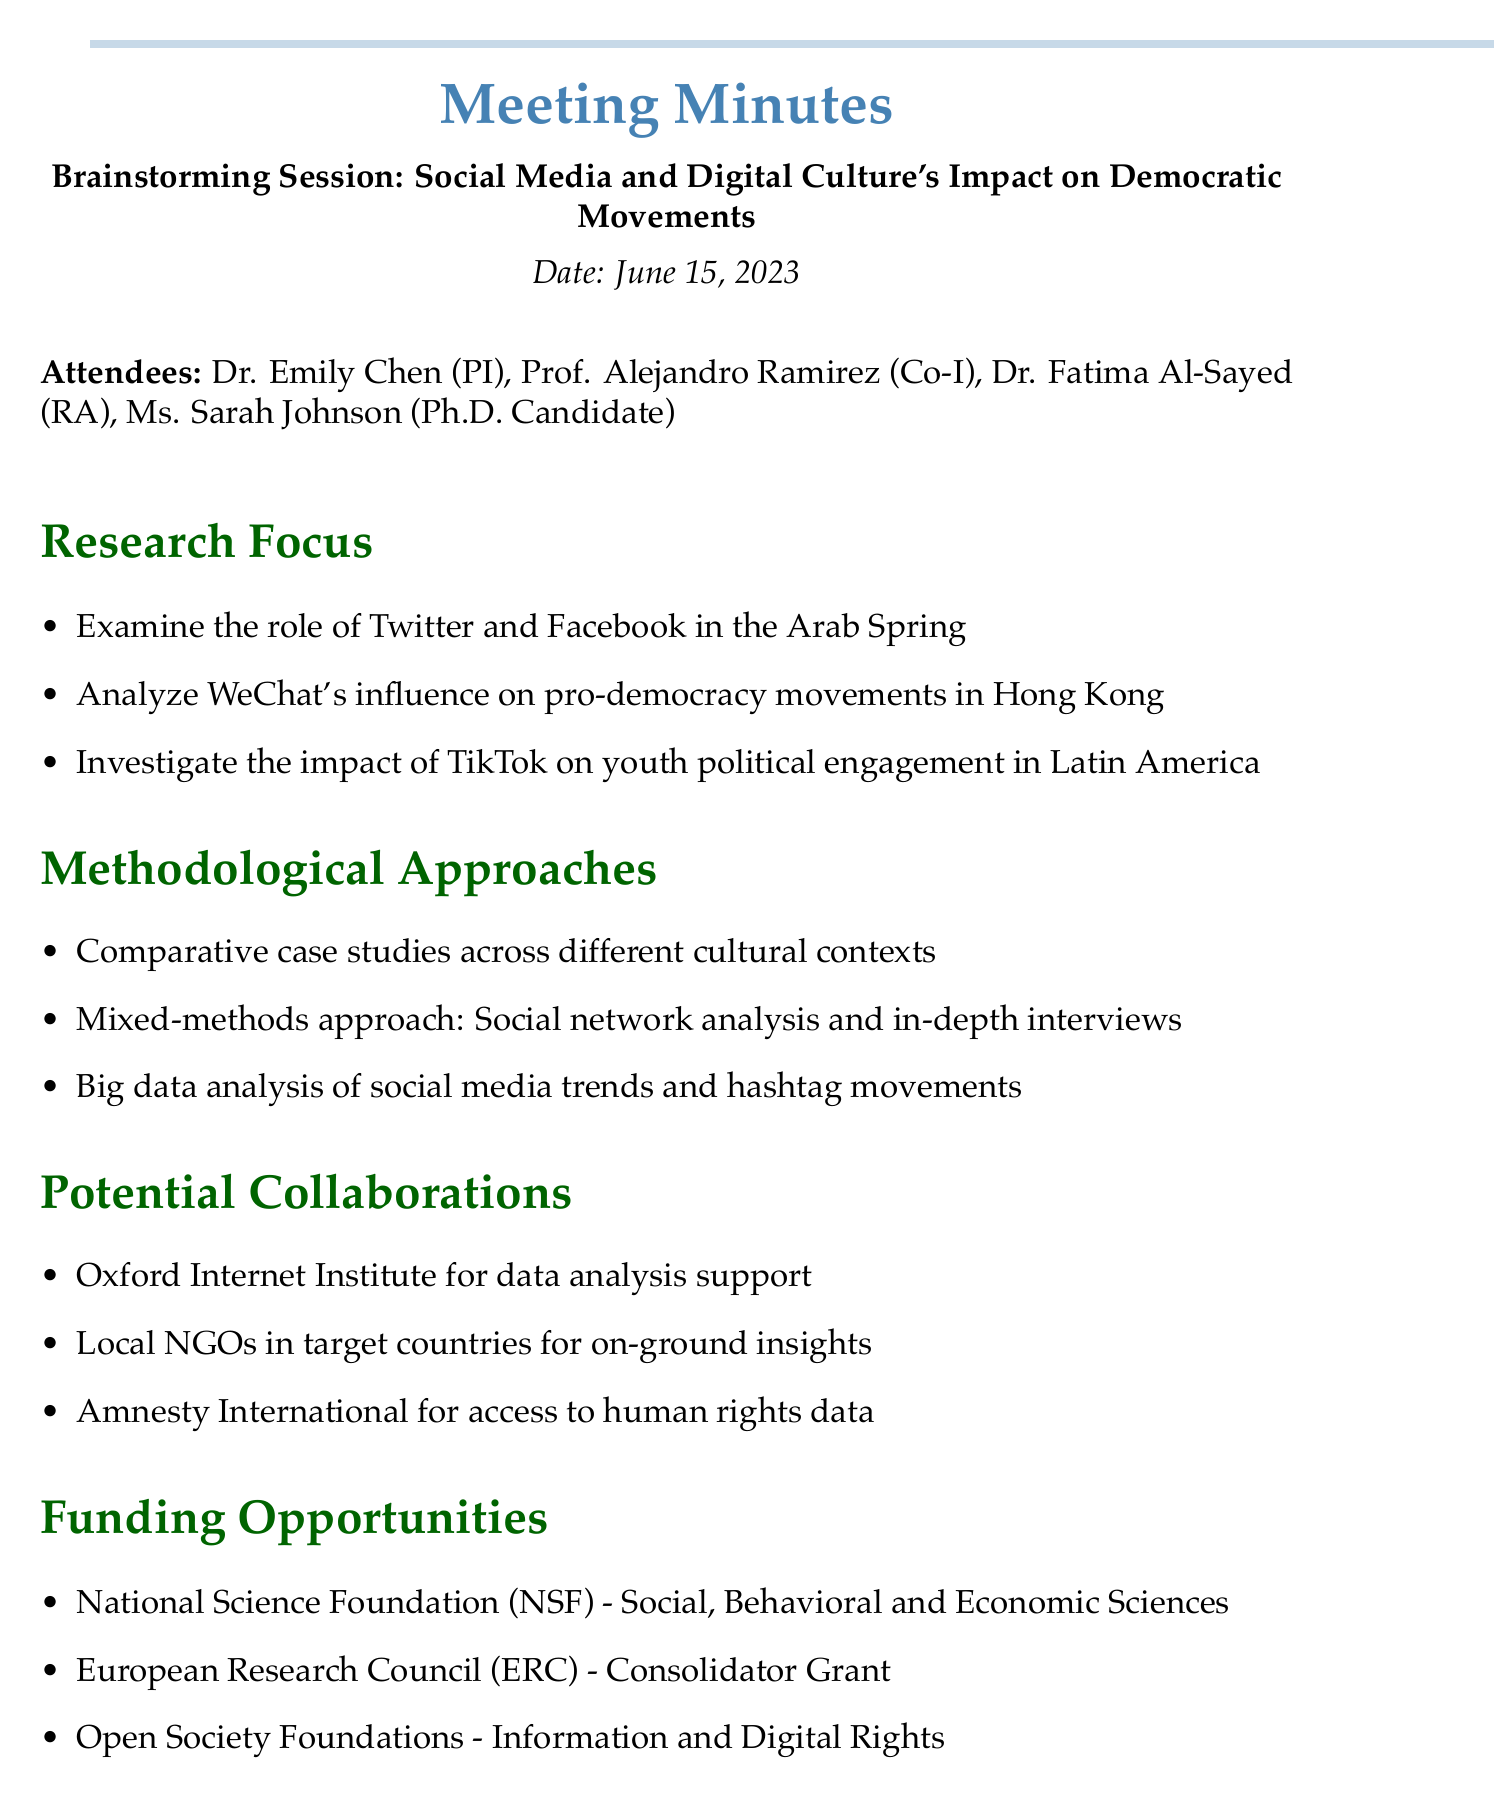What is the title of the meeting? The title of the meeting is a key piece of information found at the beginning of the document.
Answer: Brainstorming Session: Social Media and Digital Culture's Impact on Democratic Movements Who is the Principal Investigator? The document lists the attendees, including the Principal Investigator, at the beginning.
Answer: Dr. Emily Chen What date was the meeting held? The date of the meeting is clearly stated in the document's introductory section.
Answer: June 15, 2023 What social media platform is analyzed for pro-democracy movements in Hong Kong? The Research Focus section includes specific social media platforms and their context of study.
Answer: WeChat What methodological approach involves social network analysis? The Methodological Approaches section outlines different methods used in the research.
Answer: Mixed-methods approach: Social network analysis and in-depth interviews Which organization is mentioned for potential collaboration regarding human rights data? The Potential Collaborations section lists organizations that could assist in the research.
Answer: Amnesty International What is one funding opportunity mentioned in the document? The Funding Opportunities section outlines potential sources of funding for the research proposal.
Answer: National Science Foundation (NSF) - Social, Behavioral and Economic Sciences What is the first next step listed? The Next Steps section breaks down actions needed following the brainstorming session.
Answer: Draft research questions and hypotheses 